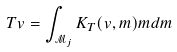Convert formula to latex. <formula><loc_0><loc_0><loc_500><loc_500>T v = \int _ { \mathcal { M } _ { j } } K _ { T } ( v , m ) m d m</formula> 